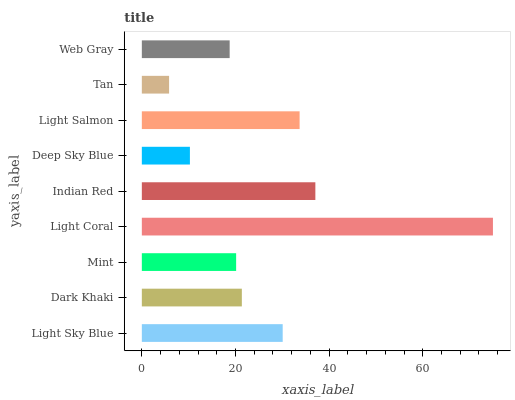Is Tan the minimum?
Answer yes or no. Yes. Is Light Coral the maximum?
Answer yes or no. Yes. Is Dark Khaki the minimum?
Answer yes or no. No. Is Dark Khaki the maximum?
Answer yes or no. No. Is Light Sky Blue greater than Dark Khaki?
Answer yes or no. Yes. Is Dark Khaki less than Light Sky Blue?
Answer yes or no. Yes. Is Dark Khaki greater than Light Sky Blue?
Answer yes or no. No. Is Light Sky Blue less than Dark Khaki?
Answer yes or no. No. Is Dark Khaki the high median?
Answer yes or no. Yes. Is Dark Khaki the low median?
Answer yes or no. Yes. Is Light Coral the high median?
Answer yes or no. No. Is Light Coral the low median?
Answer yes or no. No. 